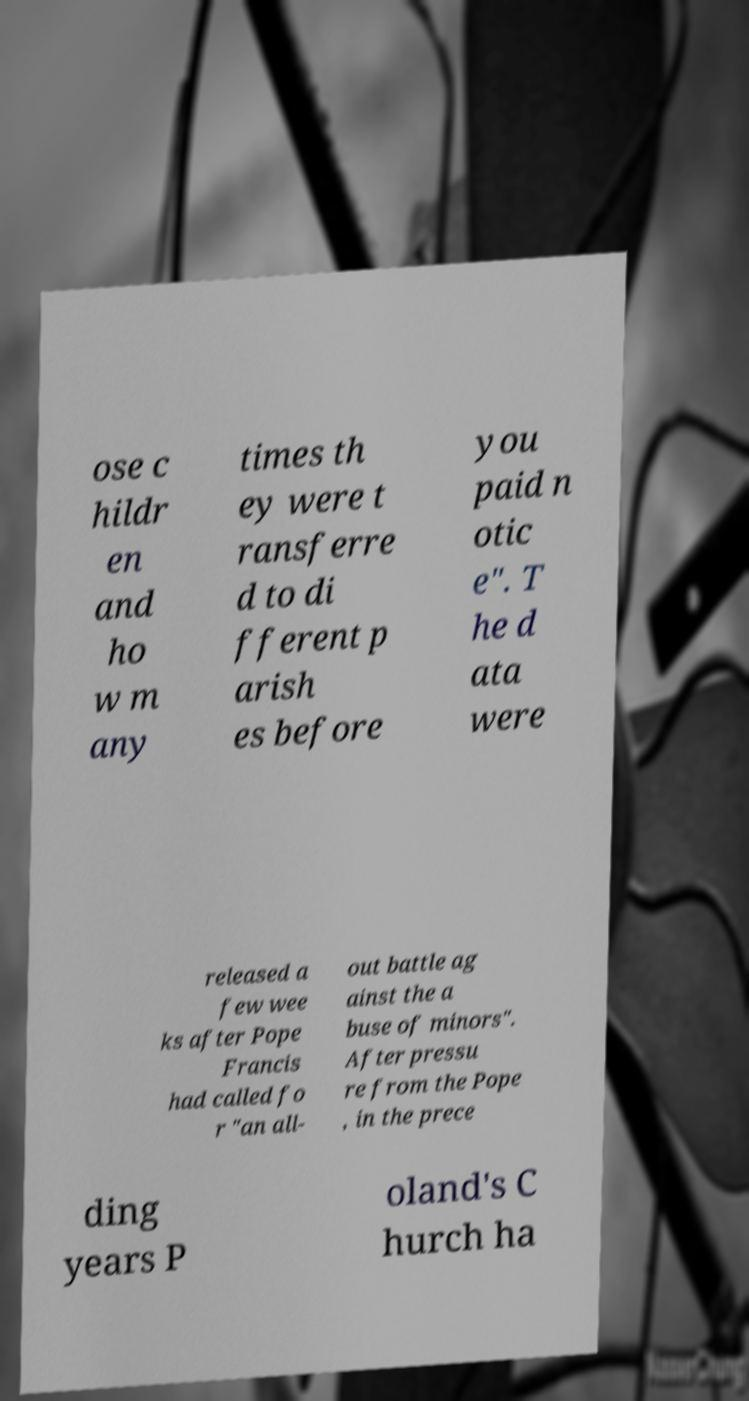Can you read and provide the text displayed in the image?This photo seems to have some interesting text. Can you extract and type it out for me? ose c hildr en and ho w m any times th ey were t ransferre d to di fferent p arish es before you paid n otic e". T he d ata were released a few wee ks after Pope Francis had called fo r "an all- out battle ag ainst the a buse of minors". After pressu re from the Pope , in the prece ding years P oland's C hurch ha 